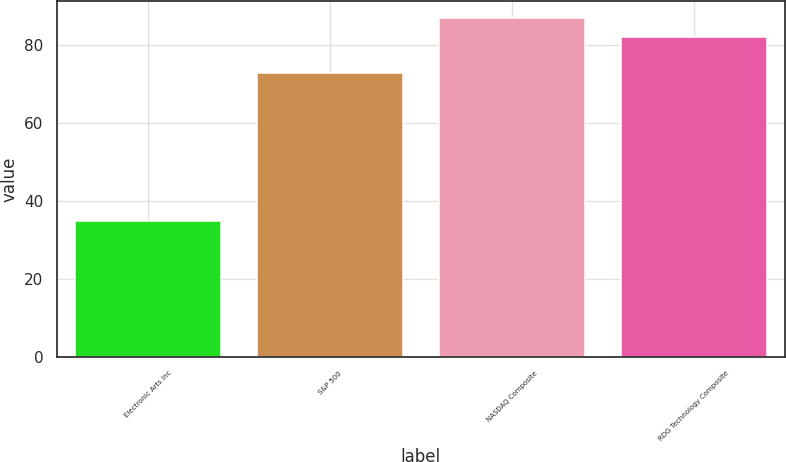Convert chart to OTSL. <chart><loc_0><loc_0><loc_500><loc_500><bar_chart><fcel>Electronic Arts Inc<fcel>S&P 500<fcel>NASDAQ Composite<fcel>RDG Technology Composite<nl><fcel>35<fcel>73<fcel>87<fcel>82<nl></chart> 